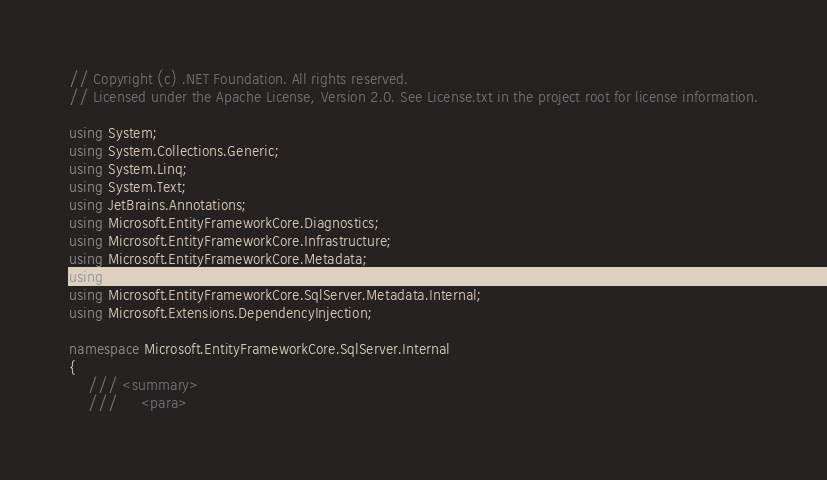Convert code to text. <code><loc_0><loc_0><loc_500><loc_500><_C#_>// Copyright (c) .NET Foundation. All rights reserved.
// Licensed under the Apache License, Version 2.0. See License.txt in the project root for license information.

using System;
using System.Collections.Generic;
using System.Linq;
using System.Text;
using JetBrains.Annotations;
using Microsoft.EntityFrameworkCore.Diagnostics;
using Microsoft.EntityFrameworkCore.Infrastructure;
using Microsoft.EntityFrameworkCore.Metadata;
using Microsoft.EntityFrameworkCore.Metadata.Internal;
using Microsoft.EntityFrameworkCore.SqlServer.Metadata.Internal;
using Microsoft.Extensions.DependencyInjection;

namespace Microsoft.EntityFrameworkCore.SqlServer.Internal
{
    /// <summary>
    ///     <para></code> 